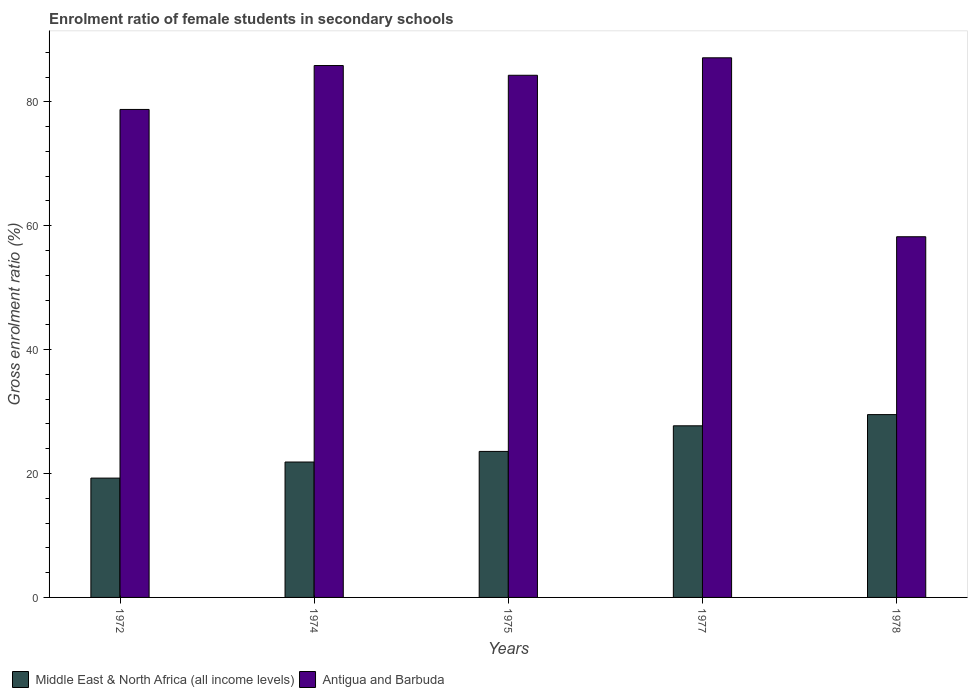How many groups of bars are there?
Provide a succinct answer. 5. Are the number of bars on each tick of the X-axis equal?
Offer a very short reply. Yes. How many bars are there on the 4th tick from the left?
Provide a short and direct response. 2. How many bars are there on the 2nd tick from the right?
Offer a very short reply. 2. What is the label of the 5th group of bars from the left?
Offer a terse response. 1978. In how many cases, is the number of bars for a given year not equal to the number of legend labels?
Your response must be concise. 0. What is the enrolment ratio of female students in secondary schools in Antigua and Barbuda in 1974?
Give a very brief answer. 85.86. Across all years, what is the maximum enrolment ratio of female students in secondary schools in Middle East & North Africa (all income levels)?
Ensure brevity in your answer.  29.51. Across all years, what is the minimum enrolment ratio of female students in secondary schools in Antigua and Barbuda?
Make the answer very short. 58.22. In which year was the enrolment ratio of female students in secondary schools in Middle East & North Africa (all income levels) minimum?
Keep it short and to the point. 1972. What is the total enrolment ratio of female students in secondary schools in Antigua and Barbuda in the graph?
Ensure brevity in your answer.  394.25. What is the difference between the enrolment ratio of female students in secondary schools in Middle East & North Africa (all income levels) in 1974 and that in 1978?
Provide a succinct answer. -7.65. What is the difference between the enrolment ratio of female students in secondary schools in Middle East & North Africa (all income levels) in 1972 and the enrolment ratio of female students in secondary schools in Antigua and Barbuda in 1978?
Your answer should be compact. -38.96. What is the average enrolment ratio of female students in secondary schools in Middle East & North Africa (all income levels) per year?
Ensure brevity in your answer.  24.38. In the year 1975, what is the difference between the enrolment ratio of female students in secondary schools in Antigua and Barbuda and enrolment ratio of female students in secondary schools in Middle East & North Africa (all income levels)?
Offer a very short reply. 60.72. In how many years, is the enrolment ratio of female students in secondary schools in Antigua and Barbuda greater than 84 %?
Keep it short and to the point. 3. What is the ratio of the enrolment ratio of female students in secondary schools in Antigua and Barbuda in 1977 to that in 1978?
Ensure brevity in your answer.  1.5. What is the difference between the highest and the second highest enrolment ratio of female students in secondary schools in Antigua and Barbuda?
Offer a terse response. 1.25. What is the difference between the highest and the lowest enrolment ratio of female students in secondary schools in Middle East & North Africa (all income levels)?
Provide a succinct answer. 10.25. What does the 1st bar from the left in 1977 represents?
Provide a short and direct response. Middle East & North Africa (all income levels). What does the 1st bar from the right in 1975 represents?
Ensure brevity in your answer.  Antigua and Barbuda. How many years are there in the graph?
Offer a terse response. 5. Are the values on the major ticks of Y-axis written in scientific E-notation?
Give a very brief answer. No. Does the graph contain any zero values?
Give a very brief answer. No. How many legend labels are there?
Make the answer very short. 2. How are the legend labels stacked?
Keep it short and to the point. Horizontal. What is the title of the graph?
Provide a short and direct response. Enrolment ratio of female students in secondary schools. Does "Northern Mariana Islands" appear as one of the legend labels in the graph?
Keep it short and to the point. No. What is the label or title of the X-axis?
Your answer should be compact. Years. What is the Gross enrolment ratio (%) of Middle East & North Africa (all income levels) in 1972?
Give a very brief answer. 19.26. What is the Gross enrolment ratio (%) in Antigua and Barbuda in 1972?
Your answer should be compact. 78.77. What is the Gross enrolment ratio (%) in Middle East & North Africa (all income levels) in 1974?
Give a very brief answer. 21.86. What is the Gross enrolment ratio (%) of Antigua and Barbuda in 1974?
Provide a short and direct response. 85.86. What is the Gross enrolment ratio (%) of Middle East & North Africa (all income levels) in 1975?
Provide a succinct answer. 23.57. What is the Gross enrolment ratio (%) of Antigua and Barbuda in 1975?
Your answer should be compact. 84.29. What is the Gross enrolment ratio (%) in Middle East & North Africa (all income levels) in 1977?
Keep it short and to the point. 27.7. What is the Gross enrolment ratio (%) in Antigua and Barbuda in 1977?
Your answer should be compact. 87.11. What is the Gross enrolment ratio (%) of Middle East & North Africa (all income levels) in 1978?
Your answer should be compact. 29.51. What is the Gross enrolment ratio (%) of Antigua and Barbuda in 1978?
Make the answer very short. 58.22. Across all years, what is the maximum Gross enrolment ratio (%) of Middle East & North Africa (all income levels)?
Ensure brevity in your answer.  29.51. Across all years, what is the maximum Gross enrolment ratio (%) of Antigua and Barbuda?
Your response must be concise. 87.11. Across all years, what is the minimum Gross enrolment ratio (%) of Middle East & North Africa (all income levels)?
Provide a short and direct response. 19.26. Across all years, what is the minimum Gross enrolment ratio (%) of Antigua and Barbuda?
Make the answer very short. 58.22. What is the total Gross enrolment ratio (%) of Middle East & North Africa (all income levels) in the graph?
Ensure brevity in your answer.  121.9. What is the total Gross enrolment ratio (%) of Antigua and Barbuda in the graph?
Provide a short and direct response. 394.25. What is the difference between the Gross enrolment ratio (%) in Middle East & North Africa (all income levels) in 1972 and that in 1974?
Ensure brevity in your answer.  -2.59. What is the difference between the Gross enrolment ratio (%) in Antigua and Barbuda in 1972 and that in 1974?
Ensure brevity in your answer.  -7.09. What is the difference between the Gross enrolment ratio (%) of Middle East & North Africa (all income levels) in 1972 and that in 1975?
Provide a short and direct response. -4.31. What is the difference between the Gross enrolment ratio (%) in Antigua and Barbuda in 1972 and that in 1975?
Offer a very short reply. -5.51. What is the difference between the Gross enrolment ratio (%) of Middle East & North Africa (all income levels) in 1972 and that in 1977?
Offer a terse response. -8.44. What is the difference between the Gross enrolment ratio (%) in Antigua and Barbuda in 1972 and that in 1977?
Give a very brief answer. -8.34. What is the difference between the Gross enrolment ratio (%) of Middle East & North Africa (all income levels) in 1972 and that in 1978?
Your response must be concise. -10.25. What is the difference between the Gross enrolment ratio (%) of Antigua and Barbuda in 1972 and that in 1978?
Give a very brief answer. 20.55. What is the difference between the Gross enrolment ratio (%) in Middle East & North Africa (all income levels) in 1974 and that in 1975?
Make the answer very short. -1.71. What is the difference between the Gross enrolment ratio (%) of Antigua and Barbuda in 1974 and that in 1975?
Offer a terse response. 1.57. What is the difference between the Gross enrolment ratio (%) in Middle East & North Africa (all income levels) in 1974 and that in 1977?
Ensure brevity in your answer.  -5.85. What is the difference between the Gross enrolment ratio (%) in Antigua and Barbuda in 1974 and that in 1977?
Make the answer very short. -1.25. What is the difference between the Gross enrolment ratio (%) in Middle East & North Africa (all income levels) in 1974 and that in 1978?
Provide a succinct answer. -7.65. What is the difference between the Gross enrolment ratio (%) of Antigua and Barbuda in 1974 and that in 1978?
Give a very brief answer. 27.64. What is the difference between the Gross enrolment ratio (%) of Middle East & North Africa (all income levels) in 1975 and that in 1977?
Offer a terse response. -4.13. What is the difference between the Gross enrolment ratio (%) of Antigua and Barbuda in 1975 and that in 1977?
Offer a terse response. -2.82. What is the difference between the Gross enrolment ratio (%) in Middle East & North Africa (all income levels) in 1975 and that in 1978?
Your response must be concise. -5.94. What is the difference between the Gross enrolment ratio (%) in Antigua and Barbuda in 1975 and that in 1978?
Keep it short and to the point. 26.07. What is the difference between the Gross enrolment ratio (%) in Middle East & North Africa (all income levels) in 1977 and that in 1978?
Offer a terse response. -1.81. What is the difference between the Gross enrolment ratio (%) of Antigua and Barbuda in 1977 and that in 1978?
Offer a very short reply. 28.89. What is the difference between the Gross enrolment ratio (%) of Middle East & North Africa (all income levels) in 1972 and the Gross enrolment ratio (%) of Antigua and Barbuda in 1974?
Offer a terse response. -66.6. What is the difference between the Gross enrolment ratio (%) of Middle East & North Africa (all income levels) in 1972 and the Gross enrolment ratio (%) of Antigua and Barbuda in 1975?
Your answer should be very brief. -65.02. What is the difference between the Gross enrolment ratio (%) in Middle East & North Africa (all income levels) in 1972 and the Gross enrolment ratio (%) in Antigua and Barbuda in 1977?
Your answer should be very brief. -67.85. What is the difference between the Gross enrolment ratio (%) in Middle East & North Africa (all income levels) in 1972 and the Gross enrolment ratio (%) in Antigua and Barbuda in 1978?
Offer a very short reply. -38.96. What is the difference between the Gross enrolment ratio (%) of Middle East & North Africa (all income levels) in 1974 and the Gross enrolment ratio (%) of Antigua and Barbuda in 1975?
Offer a very short reply. -62.43. What is the difference between the Gross enrolment ratio (%) in Middle East & North Africa (all income levels) in 1974 and the Gross enrolment ratio (%) in Antigua and Barbuda in 1977?
Provide a short and direct response. -65.25. What is the difference between the Gross enrolment ratio (%) of Middle East & North Africa (all income levels) in 1974 and the Gross enrolment ratio (%) of Antigua and Barbuda in 1978?
Your answer should be very brief. -36.36. What is the difference between the Gross enrolment ratio (%) in Middle East & North Africa (all income levels) in 1975 and the Gross enrolment ratio (%) in Antigua and Barbuda in 1977?
Your answer should be compact. -63.54. What is the difference between the Gross enrolment ratio (%) in Middle East & North Africa (all income levels) in 1975 and the Gross enrolment ratio (%) in Antigua and Barbuda in 1978?
Offer a terse response. -34.65. What is the difference between the Gross enrolment ratio (%) in Middle East & North Africa (all income levels) in 1977 and the Gross enrolment ratio (%) in Antigua and Barbuda in 1978?
Your response must be concise. -30.52. What is the average Gross enrolment ratio (%) of Middle East & North Africa (all income levels) per year?
Provide a succinct answer. 24.38. What is the average Gross enrolment ratio (%) of Antigua and Barbuda per year?
Your response must be concise. 78.85. In the year 1972, what is the difference between the Gross enrolment ratio (%) of Middle East & North Africa (all income levels) and Gross enrolment ratio (%) of Antigua and Barbuda?
Your answer should be compact. -59.51. In the year 1974, what is the difference between the Gross enrolment ratio (%) of Middle East & North Africa (all income levels) and Gross enrolment ratio (%) of Antigua and Barbuda?
Your answer should be compact. -64. In the year 1975, what is the difference between the Gross enrolment ratio (%) of Middle East & North Africa (all income levels) and Gross enrolment ratio (%) of Antigua and Barbuda?
Make the answer very short. -60.72. In the year 1977, what is the difference between the Gross enrolment ratio (%) of Middle East & North Africa (all income levels) and Gross enrolment ratio (%) of Antigua and Barbuda?
Your response must be concise. -59.4. In the year 1978, what is the difference between the Gross enrolment ratio (%) in Middle East & North Africa (all income levels) and Gross enrolment ratio (%) in Antigua and Barbuda?
Offer a terse response. -28.71. What is the ratio of the Gross enrolment ratio (%) of Middle East & North Africa (all income levels) in 1972 to that in 1974?
Ensure brevity in your answer.  0.88. What is the ratio of the Gross enrolment ratio (%) of Antigua and Barbuda in 1972 to that in 1974?
Your answer should be very brief. 0.92. What is the ratio of the Gross enrolment ratio (%) in Middle East & North Africa (all income levels) in 1972 to that in 1975?
Make the answer very short. 0.82. What is the ratio of the Gross enrolment ratio (%) of Antigua and Barbuda in 1972 to that in 1975?
Offer a terse response. 0.93. What is the ratio of the Gross enrolment ratio (%) in Middle East & North Africa (all income levels) in 1972 to that in 1977?
Give a very brief answer. 0.7. What is the ratio of the Gross enrolment ratio (%) in Antigua and Barbuda in 1972 to that in 1977?
Provide a succinct answer. 0.9. What is the ratio of the Gross enrolment ratio (%) of Middle East & North Africa (all income levels) in 1972 to that in 1978?
Make the answer very short. 0.65. What is the ratio of the Gross enrolment ratio (%) in Antigua and Barbuda in 1972 to that in 1978?
Offer a terse response. 1.35. What is the ratio of the Gross enrolment ratio (%) of Middle East & North Africa (all income levels) in 1974 to that in 1975?
Provide a succinct answer. 0.93. What is the ratio of the Gross enrolment ratio (%) of Antigua and Barbuda in 1974 to that in 1975?
Your answer should be very brief. 1.02. What is the ratio of the Gross enrolment ratio (%) of Middle East & North Africa (all income levels) in 1974 to that in 1977?
Provide a short and direct response. 0.79. What is the ratio of the Gross enrolment ratio (%) in Antigua and Barbuda in 1974 to that in 1977?
Provide a short and direct response. 0.99. What is the ratio of the Gross enrolment ratio (%) of Middle East & North Africa (all income levels) in 1974 to that in 1978?
Make the answer very short. 0.74. What is the ratio of the Gross enrolment ratio (%) of Antigua and Barbuda in 1974 to that in 1978?
Offer a very short reply. 1.47. What is the ratio of the Gross enrolment ratio (%) of Middle East & North Africa (all income levels) in 1975 to that in 1977?
Your answer should be compact. 0.85. What is the ratio of the Gross enrolment ratio (%) of Antigua and Barbuda in 1975 to that in 1977?
Make the answer very short. 0.97. What is the ratio of the Gross enrolment ratio (%) of Middle East & North Africa (all income levels) in 1975 to that in 1978?
Your response must be concise. 0.8. What is the ratio of the Gross enrolment ratio (%) of Antigua and Barbuda in 1975 to that in 1978?
Your answer should be compact. 1.45. What is the ratio of the Gross enrolment ratio (%) in Middle East & North Africa (all income levels) in 1977 to that in 1978?
Make the answer very short. 0.94. What is the ratio of the Gross enrolment ratio (%) in Antigua and Barbuda in 1977 to that in 1978?
Your answer should be very brief. 1.5. What is the difference between the highest and the second highest Gross enrolment ratio (%) of Middle East & North Africa (all income levels)?
Keep it short and to the point. 1.81. What is the difference between the highest and the second highest Gross enrolment ratio (%) of Antigua and Barbuda?
Your response must be concise. 1.25. What is the difference between the highest and the lowest Gross enrolment ratio (%) in Middle East & North Africa (all income levels)?
Keep it short and to the point. 10.25. What is the difference between the highest and the lowest Gross enrolment ratio (%) in Antigua and Barbuda?
Provide a short and direct response. 28.89. 